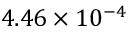Convert formula to latex. <formula><loc_0><loc_0><loc_500><loc_500>4 . 4 6 \times 1 0 ^ { - 4 }</formula> 